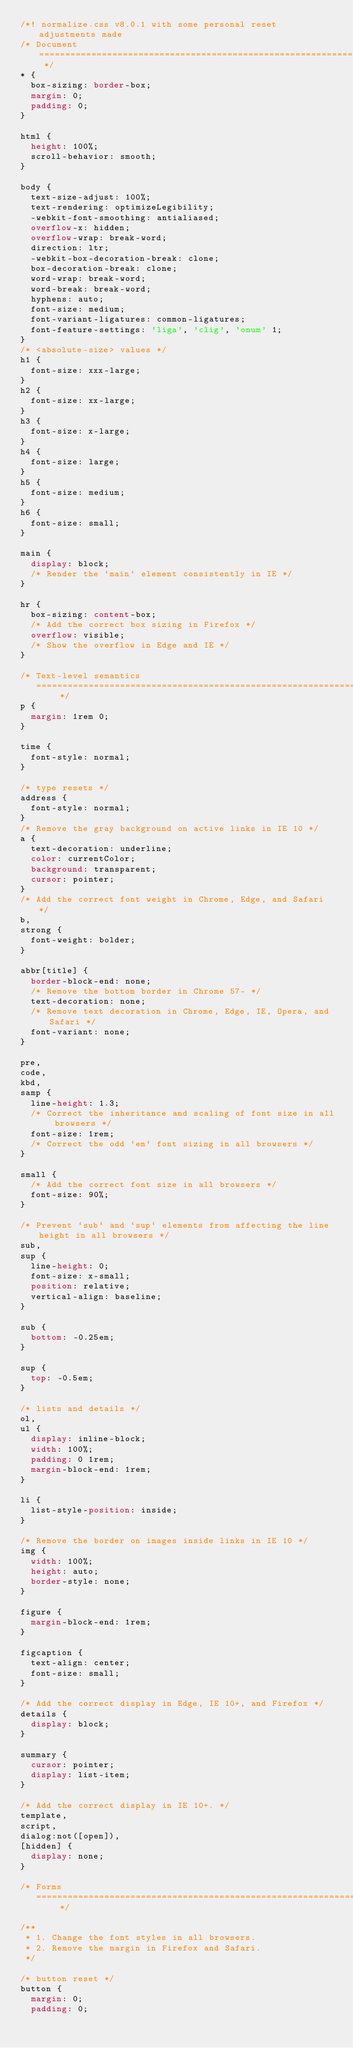<code> <loc_0><loc_0><loc_500><loc_500><_CSS_>/*! normalize.css v8.0.1 with some personal reset adjustments made
/* Document ========================================================================== */
* {
  box-sizing: border-box;
  margin: 0;
  padding: 0;
}

html {
  height: 100%;
  scroll-behavior: smooth;
}

body {
  text-size-adjust: 100%;
  text-rendering: optimizeLegibility;
  -webkit-font-smoothing: antialiased;
  overflow-x: hidden;
  overflow-wrap: break-word;
  direction: ltr;
  -webkit-box-decoration-break: clone;
  box-decoration-break: clone;
  word-wrap: break-word;
  word-break: break-word;
  hyphens: auto;
  font-size: medium;
  font-variant-ligatures: common-ligatures;
  font-feature-settings: 'liga', 'clig', 'onum' 1;
}
/* <absolute-size> values */
h1 {
  font-size: xxx-large;
}
h2 {
  font-size: xx-large;
}
h3 {
  font-size: x-large;
}
h4 {
  font-size: large;
}
h5 {
  font-size: medium;
}
h6 {
  font-size: small;
}

main {
  display: block;
  /* Render the `main` element consistently in IE */
}

hr {
  box-sizing: content-box;
  /* Add the correct box sizing in Firefox */
  overflow: visible;
  /* Show the overflow in Edge and IE */
}

/* Text-level semantics
   ========================================================================== */
p {
  margin: 1rem 0;
}

time {
  font-style: normal;
}

/* type resets */
address {
  font-style: normal;
}
/* Remove the gray background on active links in IE 10 */
a {
  text-decoration: underline;
  color: currentColor;
  background: transparent;
  cursor: pointer;
}
/* Add the correct font weight in Chrome, Edge, and Safari */
b,
strong {
  font-weight: bolder;
}

abbr[title] {
  border-block-end: none;
  /* Remove the bottom border in Chrome 57- */
  text-decoration: none;
  /* Remove text decoration in Chrome, Edge, IE, Opera, and Safari */
  font-variant: none;
}

pre,
code,
kbd,
samp {
  line-height: 1.3;
  /* Correct the inheritance and scaling of font size in all browsers */
  font-size: 1rem;
  /* Correct the odd `em` font sizing in all browsers */
}

small {
  /* Add the correct font size in all browsers */
  font-size: 90%;
}

/* Prevent `sub` and `sup` elements from affecting the line height in all browsers */
sub,
sup {
  line-height: 0;
  font-size: x-small;
  position: relative;
  vertical-align: baseline;
}

sub {
  bottom: -0.25em;
}

sup {
  top: -0.5em;
}

/* lists and details */
ol,
ul {
  display: inline-block;
  width: 100%;
  padding: 0 1rem;
  margin-block-end: 1rem;
}

li {
  list-style-position: inside;
}

/* Remove the border on images inside links in IE 10 */
img {
  width: 100%;
  height: auto;
  border-style: none;
}

figure {
  margin-block-end: 1rem;
}

figcaption {
  text-align: center;
  font-size: small;
}

/* Add the correct display in Edge, IE 10+, and Firefox */
details {
  display: block;
}

summary {
  cursor: pointer;
  display: list-item;
}

/* Add the correct display in IE 10+. */
template,
script,
dialog:not([open]),
[hidden] {
  display: none;
}

/* Forms
   ========================================================================== */

/**
 * 1. Change the font styles in all browsers.
 * 2. Remove the margin in Firefox and Safari.
 */

/* button reset */
button {
  margin: 0;
  padding: 0;</code> 